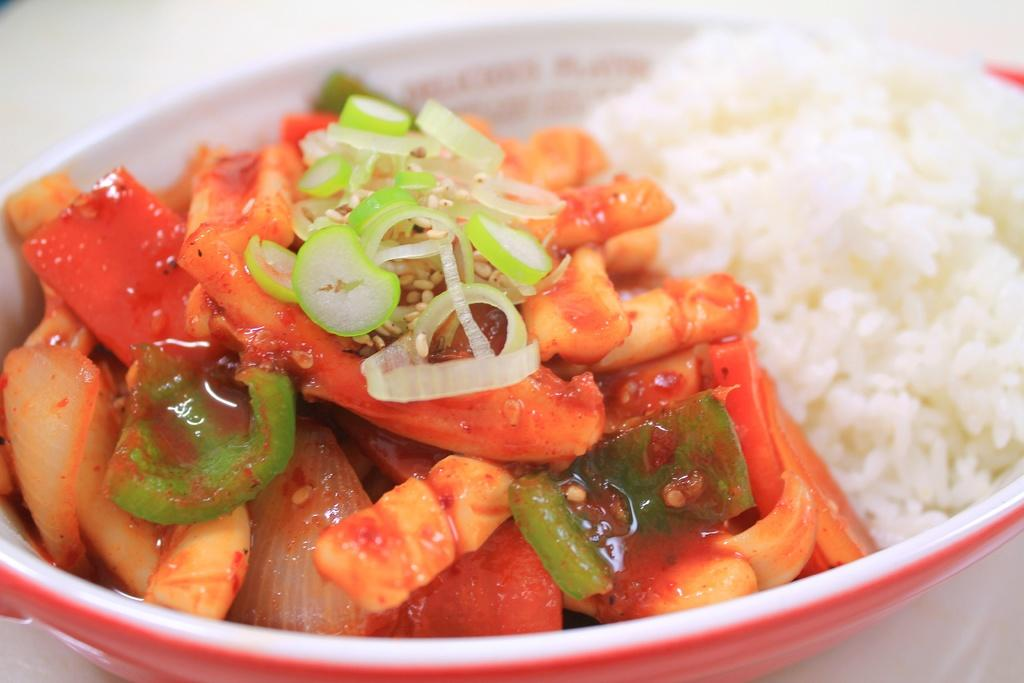What type of food can be seen in the image? There is rice in the image, along with other food. How are the rice and other food presented in the image? The rice and other food are in a bowl. What type of station can be seen in the image? There is no station present in the image. Are there any bears visible in the image? No, there are no bears present in the image. 